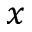<formula> <loc_0><loc_0><loc_500><loc_500>x</formula> 